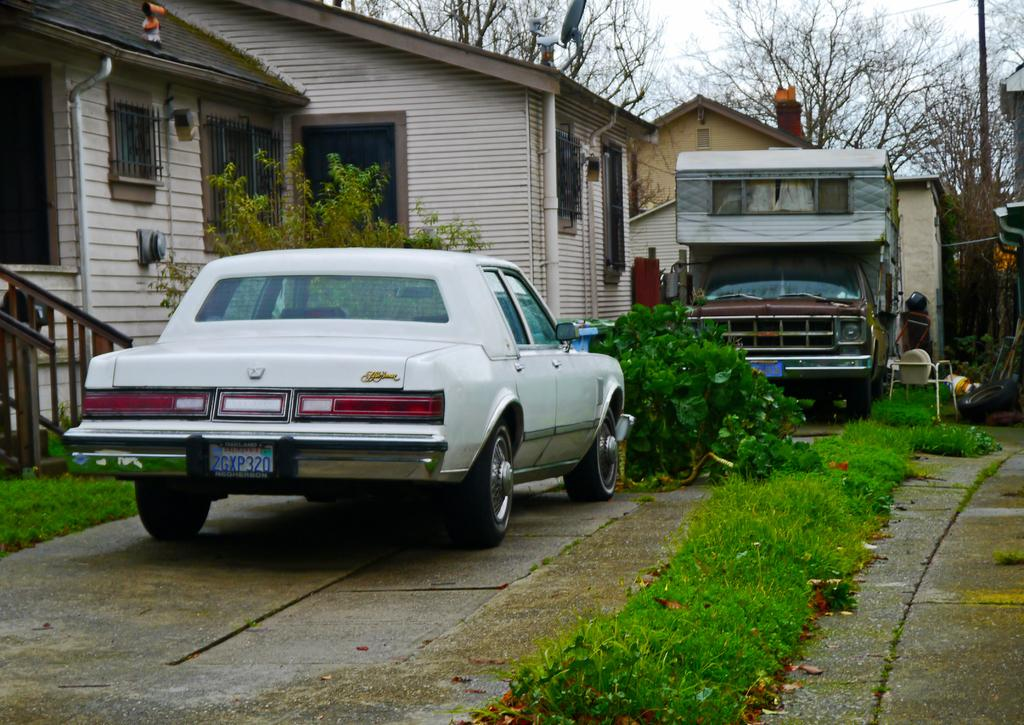What types of vehicles are in the image? There is a car and a truck in the image. Where are the vehicles located in relation to the home? The car and truck are in front of a home. What can be seen on either side of the vehicles? There is a garden on either side of the vehicles. What other natural elements are visible in the image? There are trees and the sky visible in the image. What color is the balloon that is tied to the branch of the tree in the image? There is no balloon present in the image; only a car, truck, home, gardens, trees, and the sky are visible. 